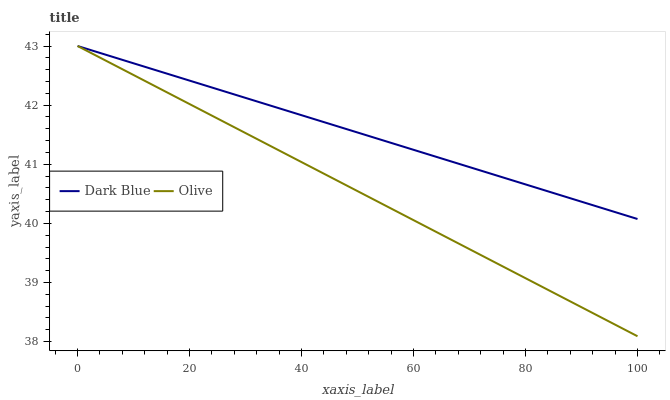Does Olive have the minimum area under the curve?
Answer yes or no. Yes. Does Dark Blue have the maximum area under the curve?
Answer yes or no. Yes. Does Dark Blue have the minimum area under the curve?
Answer yes or no. No. Is Dark Blue the smoothest?
Answer yes or no. Yes. Is Olive the roughest?
Answer yes or no. Yes. Is Dark Blue the roughest?
Answer yes or no. No. Does Olive have the lowest value?
Answer yes or no. Yes. Does Dark Blue have the lowest value?
Answer yes or no. No. Does Dark Blue have the highest value?
Answer yes or no. Yes. Does Dark Blue intersect Olive?
Answer yes or no. Yes. Is Dark Blue less than Olive?
Answer yes or no. No. Is Dark Blue greater than Olive?
Answer yes or no. No. 